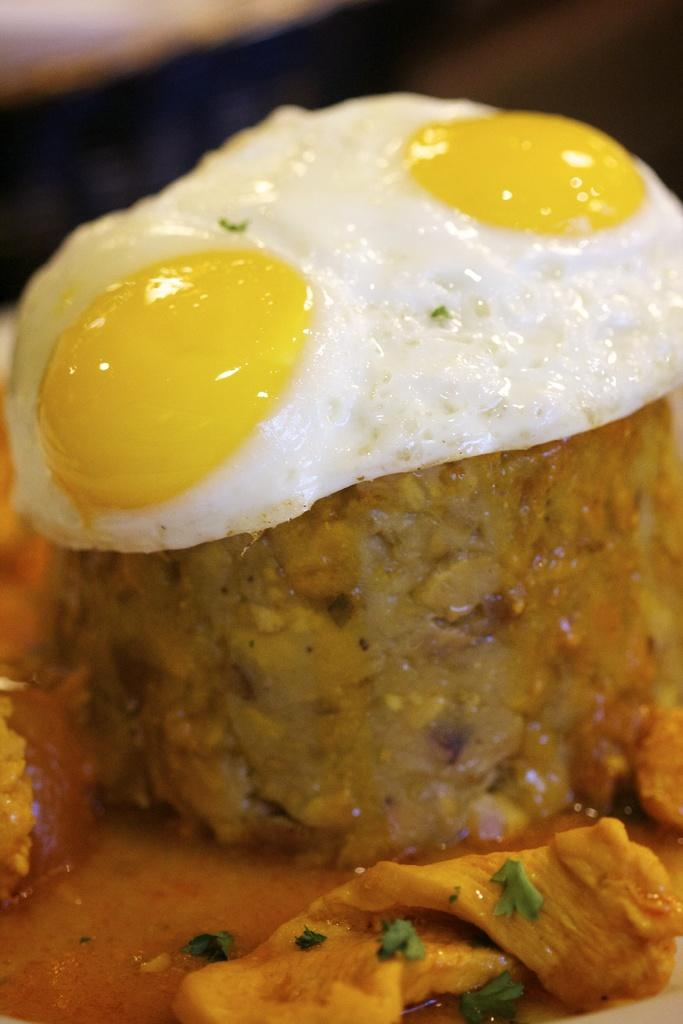What type of egg is in the image? There is a poached egg in the image. Can you describe the food in the image? The image contains food, specifically a poached egg. What type of hook is used to catch the expert in the image? There is no hook or expert present in the image; it only contains a poached egg. 